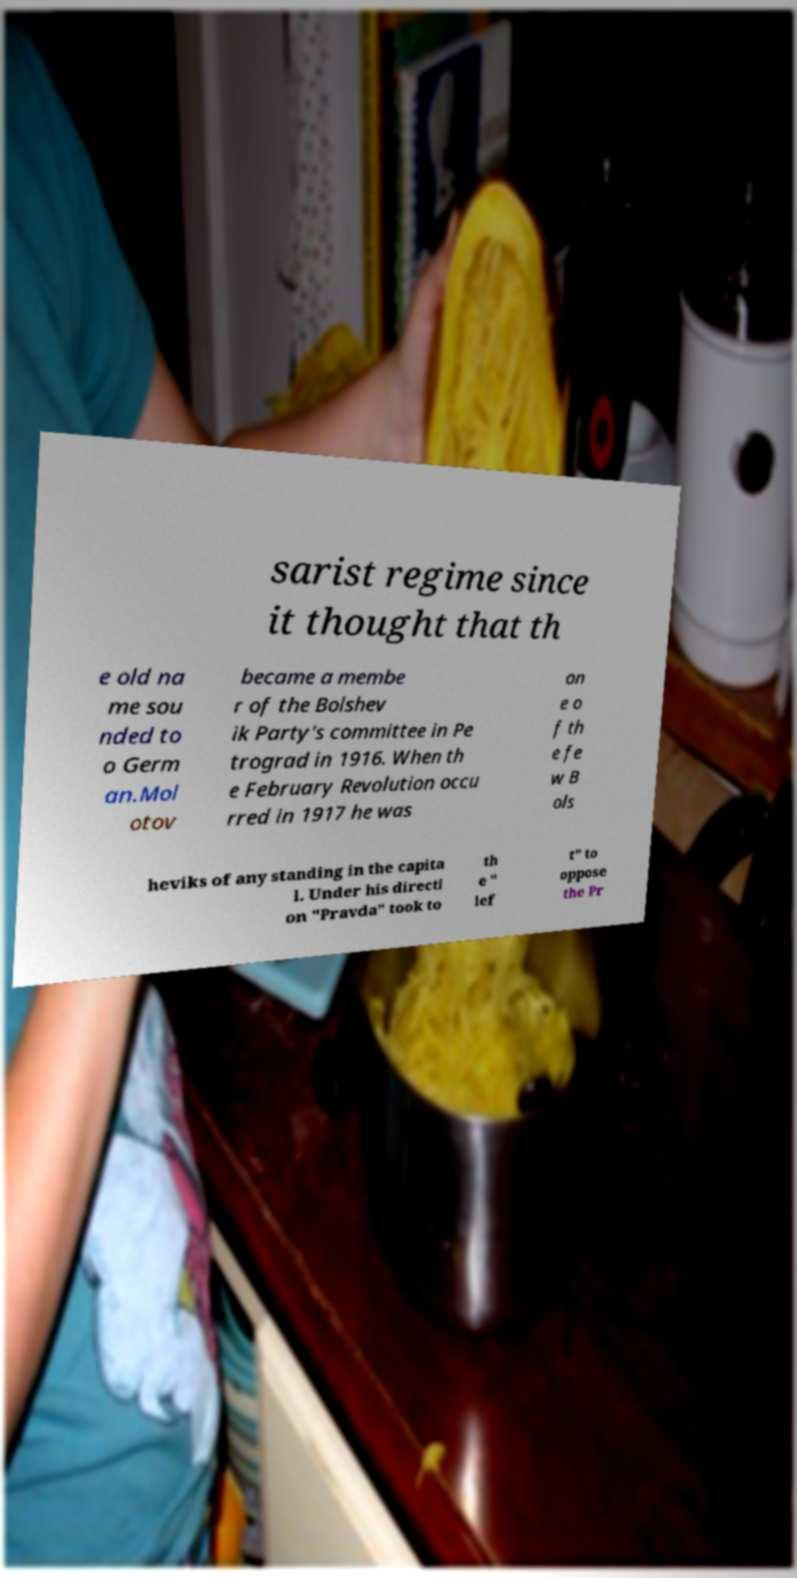For documentation purposes, I need the text within this image transcribed. Could you provide that? sarist regime since it thought that th e old na me sou nded to o Germ an.Mol otov became a membe r of the Bolshev ik Party's committee in Pe trograd in 1916. When th e February Revolution occu rred in 1917 he was on e o f th e fe w B ols heviks of any standing in the capita l. Under his directi on "Pravda" took to th e " lef t" to oppose the Pr 